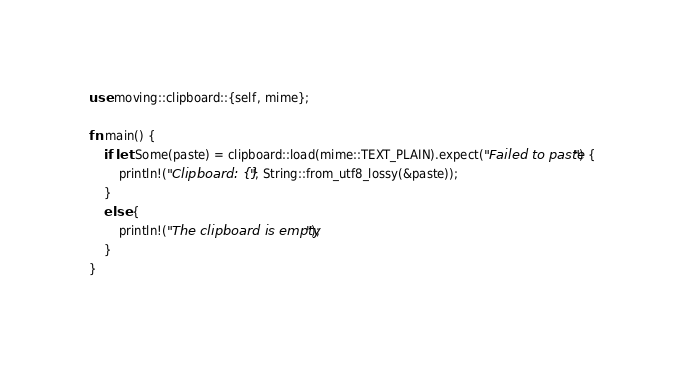Convert code to text. <code><loc_0><loc_0><loc_500><loc_500><_Rust_>use moving::clipboard::{self, mime};

fn main() {
    if let Some(paste) = clipboard::load(mime::TEXT_PLAIN).expect("Failed to paste") {
        println!("Clipboard: {}", String::from_utf8_lossy(&paste));
    }
    else {
        println!("The clipboard is empty");
    }
}
</code> 